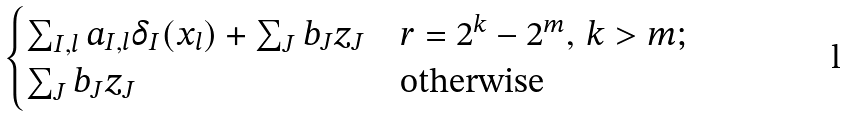Convert formula to latex. <formula><loc_0><loc_0><loc_500><loc_500>\begin{cases} \sum _ { I , l } a _ { I , l } \delta _ { I } ( x _ { l } ) + \sum _ { J } b _ { J } z _ { J } & r = 2 ^ { k } - 2 ^ { m } , \, k > m ; \\ \sum _ { J } b _ { J } z _ { J } & \text {otherwise} \end{cases}</formula> 